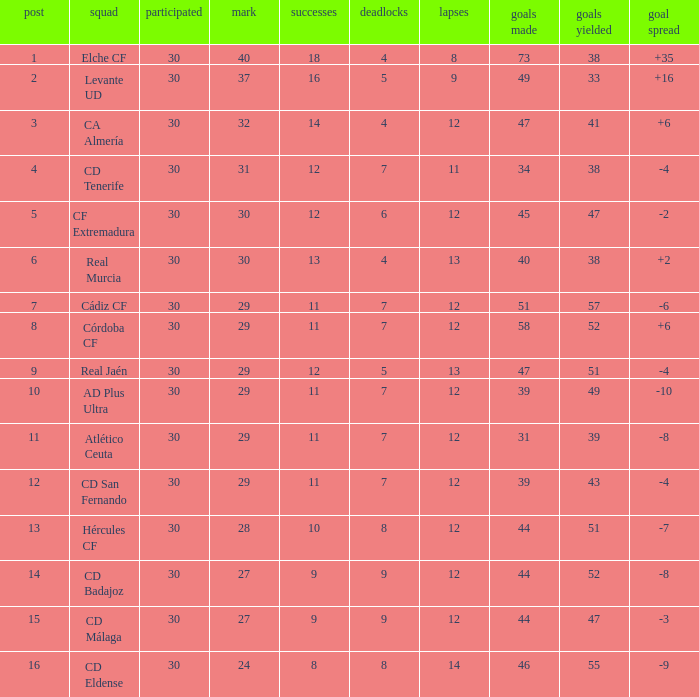What is the sum of the goals with less than 30 points, a position less than 10, and more than 57 goals against? None. 